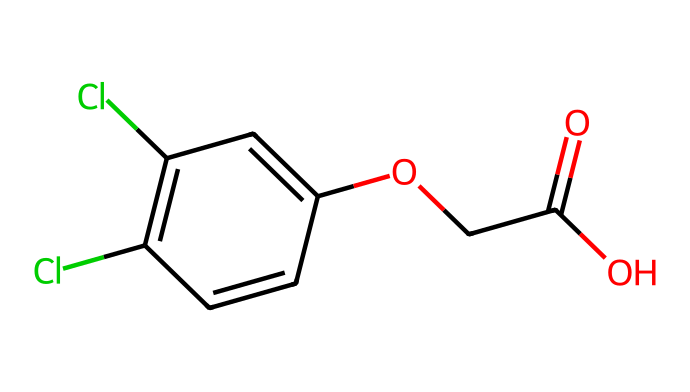What is the molecular formula of 2,4-Dichlorophenoxyacetic acid? To find the molecular formula, we can break down the SMILES representation to count the number of each type of atom present. From the structure, there are 8 Carbon (C) atoms, 7 Hydrogen (H) atoms, 2 Chlorine (Cl) atoms, 3 Oxygen (O) atoms. Therefore, the molecular formula is C8H6Cl2O3.
Answer: C8H6Cl2O3 How many chlorine atoms are present in 2,4-D? By examining the SMILES notation, we can see the representations for chlorine atoms are indicated by 'Cl'. There are two occurrences of 'Cl' in the structure.
Answer: 2 What functional groups are present in 2,4-D? Analyzing the structure, we can identify several functional groups such as a carboxylic acid (-COOH), an ether linkage (R-O-R), and the presence of chlorinated aromatic system.
Answer: carboxylic acid, ether, chlorinated aromatic Which atom is responsible for the herbicidal activity of 2,4-D? The herbicidal activity of 2,4-D can be largely attributed to the phenoxy group (which contains the ether linkage). This arrangement allows it to mimic plant hormones, leading to uncontrolled growth in weeds.
Answer: phenoxy group How many total bonds are present in the structure of 2,4-D? To determine the total bonds, we analyze the structure for single, double, and possibly aromatic bonds. In the structure, there are 8 single bonds, 3 double bonds, and the aromatic ring contributes to a total of 4 additional bonds in resonance. This results in a total of 15 bonds.
Answer: 15 What type of herbicide is 2,4-D considered? Based on its chemical structure and mode of action, 2,4-D is classified as a synthetic auxin herbicide. This classification indicates that it is a plant growth regulator that disrupts normal growth processes in targeted plants.
Answer: synthetic auxin 